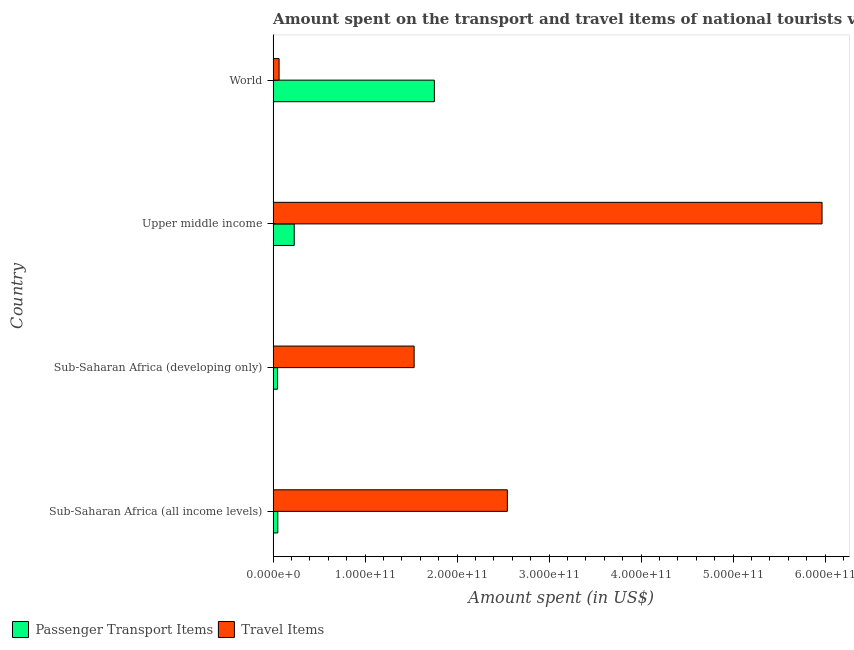How many different coloured bars are there?
Ensure brevity in your answer.  2. How many groups of bars are there?
Your answer should be very brief. 4. What is the label of the 4th group of bars from the top?
Provide a succinct answer. Sub-Saharan Africa (all income levels). In how many cases, is the number of bars for a given country not equal to the number of legend labels?
Your response must be concise. 0. What is the amount spent in travel items in World?
Give a very brief answer. 6.49e+09. Across all countries, what is the maximum amount spent on passenger transport items?
Keep it short and to the point. 1.75e+11. Across all countries, what is the minimum amount spent on passenger transport items?
Give a very brief answer. 4.82e+09. In which country was the amount spent on passenger transport items minimum?
Offer a terse response. Sub-Saharan Africa (developing only). What is the total amount spent in travel items in the graph?
Provide a short and direct response. 1.01e+12. What is the difference between the amount spent in travel items in Sub-Saharan Africa (developing only) and that in Upper middle income?
Make the answer very short. -4.43e+11. What is the difference between the amount spent on passenger transport items in World and the amount spent in travel items in Upper middle income?
Give a very brief answer. -4.21e+11. What is the average amount spent on passenger transport items per country?
Your response must be concise. 5.20e+1. What is the difference between the amount spent in travel items and amount spent on passenger transport items in Sub-Saharan Africa (all income levels)?
Your answer should be compact. 2.50e+11. In how many countries, is the amount spent on passenger transport items greater than 40000000000 US$?
Provide a short and direct response. 1. What is the ratio of the amount spent in travel items in Sub-Saharan Africa (all income levels) to that in Sub-Saharan Africa (developing only)?
Keep it short and to the point. 1.66. What is the difference between the highest and the second highest amount spent in travel items?
Make the answer very short. 3.42e+11. What is the difference between the highest and the lowest amount spent on passenger transport items?
Provide a short and direct response. 1.70e+11. In how many countries, is the amount spent on passenger transport items greater than the average amount spent on passenger transport items taken over all countries?
Keep it short and to the point. 1. Is the sum of the amount spent on passenger transport items in Sub-Saharan Africa (developing only) and Upper middle income greater than the maximum amount spent in travel items across all countries?
Offer a terse response. No. What does the 2nd bar from the top in Sub-Saharan Africa (all income levels) represents?
Ensure brevity in your answer.  Passenger Transport Items. What does the 2nd bar from the bottom in Sub-Saharan Africa (developing only) represents?
Your answer should be compact. Travel Items. How many bars are there?
Your answer should be compact. 8. Are all the bars in the graph horizontal?
Provide a succinct answer. Yes. What is the difference between two consecutive major ticks on the X-axis?
Keep it short and to the point. 1.00e+11. How many legend labels are there?
Make the answer very short. 2. What is the title of the graph?
Provide a succinct answer. Amount spent on the transport and travel items of national tourists visited in 2010. What is the label or title of the X-axis?
Your response must be concise. Amount spent (in US$). What is the label or title of the Y-axis?
Your answer should be very brief. Country. What is the Amount spent (in US$) of Passenger Transport Items in Sub-Saharan Africa (all income levels)?
Your answer should be compact. 5.09e+09. What is the Amount spent (in US$) in Travel Items in Sub-Saharan Africa (all income levels)?
Ensure brevity in your answer.  2.55e+11. What is the Amount spent (in US$) in Passenger Transport Items in Sub-Saharan Africa (developing only)?
Keep it short and to the point. 4.82e+09. What is the Amount spent (in US$) in Travel Items in Sub-Saharan Africa (developing only)?
Ensure brevity in your answer.  1.53e+11. What is the Amount spent (in US$) of Passenger Transport Items in Upper middle income?
Your answer should be compact. 2.29e+1. What is the Amount spent (in US$) of Travel Items in Upper middle income?
Provide a short and direct response. 5.97e+11. What is the Amount spent (in US$) of Passenger Transport Items in World?
Ensure brevity in your answer.  1.75e+11. What is the Amount spent (in US$) in Travel Items in World?
Ensure brevity in your answer.  6.49e+09. Across all countries, what is the maximum Amount spent (in US$) of Passenger Transport Items?
Offer a very short reply. 1.75e+11. Across all countries, what is the maximum Amount spent (in US$) of Travel Items?
Offer a terse response. 5.97e+11. Across all countries, what is the minimum Amount spent (in US$) of Passenger Transport Items?
Offer a very short reply. 4.82e+09. Across all countries, what is the minimum Amount spent (in US$) in Travel Items?
Make the answer very short. 6.49e+09. What is the total Amount spent (in US$) in Passenger Transport Items in the graph?
Ensure brevity in your answer.  2.08e+11. What is the total Amount spent (in US$) of Travel Items in the graph?
Your response must be concise. 1.01e+12. What is the difference between the Amount spent (in US$) in Passenger Transport Items in Sub-Saharan Africa (all income levels) and that in Sub-Saharan Africa (developing only)?
Your response must be concise. 2.67e+08. What is the difference between the Amount spent (in US$) of Travel Items in Sub-Saharan Africa (all income levels) and that in Sub-Saharan Africa (developing only)?
Your response must be concise. 1.01e+11. What is the difference between the Amount spent (in US$) of Passenger Transport Items in Sub-Saharan Africa (all income levels) and that in Upper middle income?
Make the answer very short. -1.79e+1. What is the difference between the Amount spent (in US$) in Travel Items in Sub-Saharan Africa (all income levels) and that in Upper middle income?
Ensure brevity in your answer.  -3.42e+11. What is the difference between the Amount spent (in US$) of Passenger Transport Items in Sub-Saharan Africa (all income levels) and that in World?
Your response must be concise. -1.70e+11. What is the difference between the Amount spent (in US$) in Travel Items in Sub-Saharan Africa (all income levels) and that in World?
Your answer should be compact. 2.48e+11. What is the difference between the Amount spent (in US$) in Passenger Transport Items in Sub-Saharan Africa (developing only) and that in Upper middle income?
Your response must be concise. -1.81e+1. What is the difference between the Amount spent (in US$) of Travel Items in Sub-Saharan Africa (developing only) and that in Upper middle income?
Provide a succinct answer. -4.43e+11. What is the difference between the Amount spent (in US$) of Passenger Transport Items in Sub-Saharan Africa (developing only) and that in World?
Your answer should be compact. -1.70e+11. What is the difference between the Amount spent (in US$) of Travel Items in Sub-Saharan Africa (developing only) and that in World?
Your answer should be compact. 1.47e+11. What is the difference between the Amount spent (in US$) of Passenger Transport Items in Upper middle income and that in World?
Your response must be concise. -1.52e+11. What is the difference between the Amount spent (in US$) of Travel Items in Upper middle income and that in World?
Offer a very short reply. 5.90e+11. What is the difference between the Amount spent (in US$) of Passenger Transport Items in Sub-Saharan Africa (all income levels) and the Amount spent (in US$) of Travel Items in Sub-Saharan Africa (developing only)?
Make the answer very short. -1.48e+11. What is the difference between the Amount spent (in US$) in Passenger Transport Items in Sub-Saharan Africa (all income levels) and the Amount spent (in US$) in Travel Items in Upper middle income?
Offer a very short reply. -5.92e+11. What is the difference between the Amount spent (in US$) in Passenger Transport Items in Sub-Saharan Africa (all income levels) and the Amount spent (in US$) in Travel Items in World?
Offer a very short reply. -1.41e+09. What is the difference between the Amount spent (in US$) of Passenger Transport Items in Sub-Saharan Africa (developing only) and the Amount spent (in US$) of Travel Items in Upper middle income?
Keep it short and to the point. -5.92e+11. What is the difference between the Amount spent (in US$) in Passenger Transport Items in Sub-Saharan Africa (developing only) and the Amount spent (in US$) in Travel Items in World?
Keep it short and to the point. -1.67e+09. What is the difference between the Amount spent (in US$) of Passenger Transport Items in Upper middle income and the Amount spent (in US$) of Travel Items in World?
Keep it short and to the point. 1.64e+1. What is the average Amount spent (in US$) of Passenger Transport Items per country?
Ensure brevity in your answer.  5.20e+1. What is the average Amount spent (in US$) in Travel Items per country?
Make the answer very short. 2.53e+11. What is the difference between the Amount spent (in US$) of Passenger Transport Items and Amount spent (in US$) of Travel Items in Sub-Saharan Africa (all income levels)?
Your response must be concise. -2.50e+11. What is the difference between the Amount spent (in US$) in Passenger Transport Items and Amount spent (in US$) in Travel Items in Sub-Saharan Africa (developing only)?
Make the answer very short. -1.48e+11. What is the difference between the Amount spent (in US$) of Passenger Transport Items and Amount spent (in US$) of Travel Items in Upper middle income?
Your answer should be very brief. -5.74e+11. What is the difference between the Amount spent (in US$) of Passenger Transport Items and Amount spent (in US$) of Travel Items in World?
Provide a short and direct response. 1.69e+11. What is the ratio of the Amount spent (in US$) in Passenger Transport Items in Sub-Saharan Africa (all income levels) to that in Sub-Saharan Africa (developing only)?
Give a very brief answer. 1.06. What is the ratio of the Amount spent (in US$) in Travel Items in Sub-Saharan Africa (all income levels) to that in Sub-Saharan Africa (developing only)?
Make the answer very short. 1.66. What is the ratio of the Amount spent (in US$) in Passenger Transport Items in Sub-Saharan Africa (all income levels) to that in Upper middle income?
Your answer should be compact. 0.22. What is the ratio of the Amount spent (in US$) of Travel Items in Sub-Saharan Africa (all income levels) to that in Upper middle income?
Ensure brevity in your answer.  0.43. What is the ratio of the Amount spent (in US$) in Passenger Transport Items in Sub-Saharan Africa (all income levels) to that in World?
Provide a short and direct response. 0.03. What is the ratio of the Amount spent (in US$) in Travel Items in Sub-Saharan Africa (all income levels) to that in World?
Provide a succinct answer. 39.22. What is the ratio of the Amount spent (in US$) in Passenger Transport Items in Sub-Saharan Africa (developing only) to that in Upper middle income?
Provide a short and direct response. 0.21. What is the ratio of the Amount spent (in US$) of Travel Items in Sub-Saharan Africa (developing only) to that in Upper middle income?
Make the answer very short. 0.26. What is the ratio of the Amount spent (in US$) in Passenger Transport Items in Sub-Saharan Africa (developing only) to that in World?
Offer a terse response. 0.03. What is the ratio of the Amount spent (in US$) in Travel Items in Sub-Saharan Africa (developing only) to that in World?
Your response must be concise. 23.61. What is the ratio of the Amount spent (in US$) in Passenger Transport Items in Upper middle income to that in World?
Keep it short and to the point. 0.13. What is the ratio of the Amount spent (in US$) of Travel Items in Upper middle income to that in World?
Offer a very short reply. 91.91. What is the difference between the highest and the second highest Amount spent (in US$) of Passenger Transport Items?
Give a very brief answer. 1.52e+11. What is the difference between the highest and the second highest Amount spent (in US$) in Travel Items?
Give a very brief answer. 3.42e+11. What is the difference between the highest and the lowest Amount spent (in US$) of Passenger Transport Items?
Keep it short and to the point. 1.70e+11. What is the difference between the highest and the lowest Amount spent (in US$) in Travel Items?
Ensure brevity in your answer.  5.90e+11. 